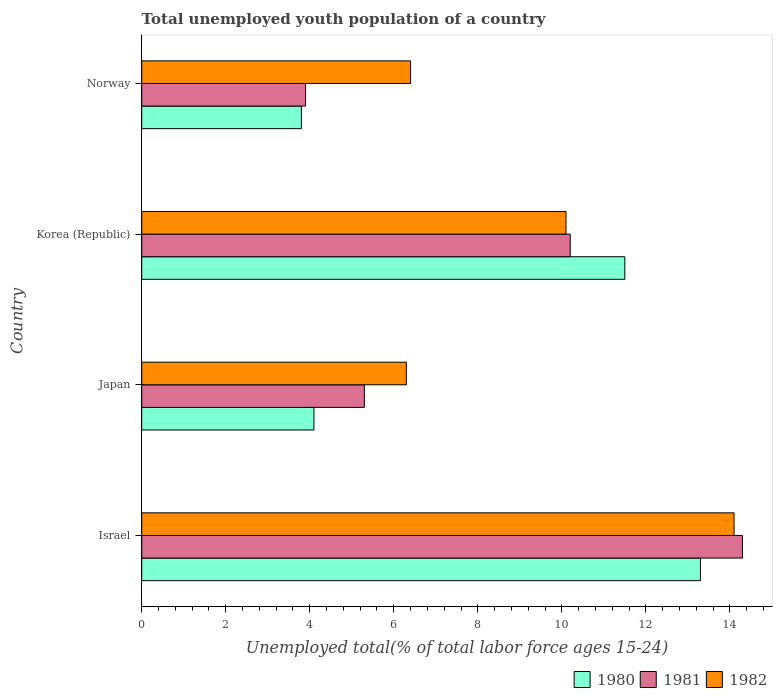How many different coloured bars are there?
Provide a succinct answer. 3. How many groups of bars are there?
Your answer should be compact. 4. Are the number of bars on each tick of the Y-axis equal?
Your response must be concise. Yes. How many bars are there on the 2nd tick from the top?
Your response must be concise. 3. In how many cases, is the number of bars for a given country not equal to the number of legend labels?
Your response must be concise. 0. What is the percentage of total unemployed youth population of a country in 1980 in Japan?
Make the answer very short. 4.1. Across all countries, what is the maximum percentage of total unemployed youth population of a country in 1980?
Provide a short and direct response. 13.3. Across all countries, what is the minimum percentage of total unemployed youth population of a country in 1982?
Make the answer very short. 6.3. What is the total percentage of total unemployed youth population of a country in 1982 in the graph?
Give a very brief answer. 36.9. What is the difference between the percentage of total unemployed youth population of a country in 1980 in Korea (Republic) and that in Norway?
Make the answer very short. 7.7. What is the difference between the percentage of total unemployed youth population of a country in 1981 in Israel and the percentage of total unemployed youth population of a country in 1980 in Japan?
Ensure brevity in your answer.  10.2. What is the average percentage of total unemployed youth population of a country in 1981 per country?
Offer a terse response. 8.43. What is the difference between the percentage of total unemployed youth population of a country in 1980 and percentage of total unemployed youth population of a country in 1981 in Japan?
Give a very brief answer. -1.2. In how many countries, is the percentage of total unemployed youth population of a country in 1980 greater than 14 %?
Offer a terse response. 0. What is the ratio of the percentage of total unemployed youth population of a country in 1982 in Japan to that in Korea (Republic)?
Provide a short and direct response. 0.62. What is the difference between the highest and the second highest percentage of total unemployed youth population of a country in 1981?
Your response must be concise. 4.1. What is the difference between the highest and the lowest percentage of total unemployed youth population of a country in 1980?
Ensure brevity in your answer.  9.5. What does the 2nd bar from the top in Japan represents?
Give a very brief answer. 1981. What does the 2nd bar from the bottom in Korea (Republic) represents?
Keep it short and to the point. 1981. How many bars are there?
Provide a succinct answer. 12. What is the difference between two consecutive major ticks on the X-axis?
Offer a terse response. 2. Are the values on the major ticks of X-axis written in scientific E-notation?
Provide a short and direct response. No. Does the graph contain any zero values?
Your answer should be very brief. No. Where does the legend appear in the graph?
Provide a short and direct response. Bottom right. What is the title of the graph?
Your answer should be very brief. Total unemployed youth population of a country. Does "1993" appear as one of the legend labels in the graph?
Ensure brevity in your answer.  No. What is the label or title of the X-axis?
Offer a terse response. Unemployed total(% of total labor force ages 15-24). What is the Unemployed total(% of total labor force ages 15-24) of 1980 in Israel?
Keep it short and to the point. 13.3. What is the Unemployed total(% of total labor force ages 15-24) in 1981 in Israel?
Your answer should be very brief. 14.3. What is the Unemployed total(% of total labor force ages 15-24) of 1982 in Israel?
Your answer should be compact. 14.1. What is the Unemployed total(% of total labor force ages 15-24) in 1980 in Japan?
Offer a terse response. 4.1. What is the Unemployed total(% of total labor force ages 15-24) in 1981 in Japan?
Provide a short and direct response. 5.3. What is the Unemployed total(% of total labor force ages 15-24) of 1982 in Japan?
Your answer should be compact. 6.3. What is the Unemployed total(% of total labor force ages 15-24) of 1981 in Korea (Republic)?
Provide a succinct answer. 10.2. What is the Unemployed total(% of total labor force ages 15-24) of 1982 in Korea (Republic)?
Make the answer very short. 10.1. What is the Unemployed total(% of total labor force ages 15-24) in 1980 in Norway?
Provide a succinct answer. 3.8. What is the Unemployed total(% of total labor force ages 15-24) of 1981 in Norway?
Offer a terse response. 3.9. What is the Unemployed total(% of total labor force ages 15-24) in 1982 in Norway?
Your answer should be very brief. 6.4. Across all countries, what is the maximum Unemployed total(% of total labor force ages 15-24) of 1980?
Offer a terse response. 13.3. Across all countries, what is the maximum Unemployed total(% of total labor force ages 15-24) of 1981?
Provide a short and direct response. 14.3. Across all countries, what is the maximum Unemployed total(% of total labor force ages 15-24) of 1982?
Provide a short and direct response. 14.1. Across all countries, what is the minimum Unemployed total(% of total labor force ages 15-24) of 1980?
Give a very brief answer. 3.8. Across all countries, what is the minimum Unemployed total(% of total labor force ages 15-24) in 1981?
Provide a succinct answer. 3.9. Across all countries, what is the minimum Unemployed total(% of total labor force ages 15-24) of 1982?
Your response must be concise. 6.3. What is the total Unemployed total(% of total labor force ages 15-24) of 1980 in the graph?
Make the answer very short. 32.7. What is the total Unemployed total(% of total labor force ages 15-24) of 1981 in the graph?
Your answer should be compact. 33.7. What is the total Unemployed total(% of total labor force ages 15-24) of 1982 in the graph?
Ensure brevity in your answer.  36.9. What is the difference between the Unemployed total(% of total labor force ages 15-24) in 1982 in Israel and that in Japan?
Ensure brevity in your answer.  7.8. What is the difference between the Unemployed total(% of total labor force ages 15-24) in 1980 in Israel and that in Korea (Republic)?
Provide a short and direct response. 1.8. What is the difference between the Unemployed total(% of total labor force ages 15-24) in 1981 in Israel and that in Korea (Republic)?
Ensure brevity in your answer.  4.1. What is the difference between the Unemployed total(% of total labor force ages 15-24) in 1982 in Israel and that in Korea (Republic)?
Offer a very short reply. 4. What is the difference between the Unemployed total(% of total labor force ages 15-24) in 1982 in Israel and that in Norway?
Your answer should be very brief. 7.7. What is the difference between the Unemployed total(% of total labor force ages 15-24) of 1981 in Japan and that in Korea (Republic)?
Make the answer very short. -4.9. What is the difference between the Unemployed total(% of total labor force ages 15-24) of 1982 in Japan and that in Korea (Republic)?
Give a very brief answer. -3.8. What is the difference between the Unemployed total(% of total labor force ages 15-24) of 1981 in Japan and that in Norway?
Your answer should be compact. 1.4. What is the difference between the Unemployed total(% of total labor force ages 15-24) of 1980 in Israel and the Unemployed total(% of total labor force ages 15-24) of 1981 in Japan?
Provide a succinct answer. 8. What is the difference between the Unemployed total(% of total labor force ages 15-24) of 1980 in Israel and the Unemployed total(% of total labor force ages 15-24) of 1982 in Japan?
Make the answer very short. 7. What is the difference between the Unemployed total(% of total labor force ages 15-24) of 1981 in Israel and the Unemployed total(% of total labor force ages 15-24) of 1982 in Japan?
Provide a short and direct response. 8. What is the difference between the Unemployed total(% of total labor force ages 15-24) of 1980 in Israel and the Unemployed total(% of total labor force ages 15-24) of 1981 in Korea (Republic)?
Keep it short and to the point. 3.1. What is the difference between the Unemployed total(% of total labor force ages 15-24) of 1980 in Israel and the Unemployed total(% of total labor force ages 15-24) of 1982 in Korea (Republic)?
Ensure brevity in your answer.  3.2. What is the difference between the Unemployed total(% of total labor force ages 15-24) in 1981 in Israel and the Unemployed total(% of total labor force ages 15-24) in 1982 in Korea (Republic)?
Offer a terse response. 4.2. What is the difference between the Unemployed total(% of total labor force ages 15-24) in 1980 in Israel and the Unemployed total(% of total labor force ages 15-24) in 1982 in Norway?
Keep it short and to the point. 6.9. What is the difference between the Unemployed total(% of total labor force ages 15-24) in 1981 in Israel and the Unemployed total(% of total labor force ages 15-24) in 1982 in Norway?
Offer a very short reply. 7.9. What is the difference between the Unemployed total(% of total labor force ages 15-24) in 1981 in Japan and the Unemployed total(% of total labor force ages 15-24) in 1982 in Korea (Republic)?
Keep it short and to the point. -4.8. What is the difference between the Unemployed total(% of total labor force ages 15-24) of 1980 in Japan and the Unemployed total(% of total labor force ages 15-24) of 1982 in Norway?
Your response must be concise. -2.3. What is the difference between the Unemployed total(% of total labor force ages 15-24) of 1980 in Korea (Republic) and the Unemployed total(% of total labor force ages 15-24) of 1981 in Norway?
Keep it short and to the point. 7.6. What is the difference between the Unemployed total(% of total labor force ages 15-24) in 1980 in Korea (Republic) and the Unemployed total(% of total labor force ages 15-24) in 1982 in Norway?
Your answer should be compact. 5.1. What is the difference between the Unemployed total(% of total labor force ages 15-24) in 1981 in Korea (Republic) and the Unemployed total(% of total labor force ages 15-24) in 1982 in Norway?
Provide a succinct answer. 3.8. What is the average Unemployed total(% of total labor force ages 15-24) in 1980 per country?
Offer a very short reply. 8.18. What is the average Unemployed total(% of total labor force ages 15-24) in 1981 per country?
Ensure brevity in your answer.  8.43. What is the average Unemployed total(% of total labor force ages 15-24) of 1982 per country?
Offer a very short reply. 9.22. What is the difference between the Unemployed total(% of total labor force ages 15-24) in 1980 and Unemployed total(% of total labor force ages 15-24) in 1981 in Israel?
Ensure brevity in your answer.  -1. What is the difference between the Unemployed total(% of total labor force ages 15-24) of 1980 and Unemployed total(% of total labor force ages 15-24) of 1982 in Israel?
Provide a short and direct response. -0.8. What is the difference between the Unemployed total(% of total labor force ages 15-24) of 1980 and Unemployed total(% of total labor force ages 15-24) of 1981 in Japan?
Your answer should be very brief. -1.2. What is the difference between the Unemployed total(% of total labor force ages 15-24) in 1980 and Unemployed total(% of total labor force ages 15-24) in 1981 in Korea (Republic)?
Your answer should be compact. 1.3. What is the difference between the Unemployed total(% of total labor force ages 15-24) in 1981 and Unemployed total(% of total labor force ages 15-24) in 1982 in Korea (Republic)?
Your response must be concise. 0.1. What is the difference between the Unemployed total(% of total labor force ages 15-24) in 1980 and Unemployed total(% of total labor force ages 15-24) in 1982 in Norway?
Ensure brevity in your answer.  -2.6. What is the ratio of the Unemployed total(% of total labor force ages 15-24) of 1980 in Israel to that in Japan?
Provide a succinct answer. 3.24. What is the ratio of the Unemployed total(% of total labor force ages 15-24) of 1981 in Israel to that in Japan?
Provide a short and direct response. 2.7. What is the ratio of the Unemployed total(% of total labor force ages 15-24) of 1982 in Israel to that in Japan?
Make the answer very short. 2.24. What is the ratio of the Unemployed total(% of total labor force ages 15-24) in 1980 in Israel to that in Korea (Republic)?
Ensure brevity in your answer.  1.16. What is the ratio of the Unemployed total(% of total labor force ages 15-24) of 1981 in Israel to that in Korea (Republic)?
Make the answer very short. 1.4. What is the ratio of the Unemployed total(% of total labor force ages 15-24) of 1982 in Israel to that in Korea (Republic)?
Offer a terse response. 1.4. What is the ratio of the Unemployed total(% of total labor force ages 15-24) of 1980 in Israel to that in Norway?
Keep it short and to the point. 3.5. What is the ratio of the Unemployed total(% of total labor force ages 15-24) of 1981 in Israel to that in Norway?
Keep it short and to the point. 3.67. What is the ratio of the Unemployed total(% of total labor force ages 15-24) of 1982 in Israel to that in Norway?
Provide a succinct answer. 2.2. What is the ratio of the Unemployed total(% of total labor force ages 15-24) of 1980 in Japan to that in Korea (Republic)?
Provide a succinct answer. 0.36. What is the ratio of the Unemployed total(% of total labor force ages 15-24) in 1981 in Japan to that in Korea (Republic)?
Make the answer very short. 0.52. What is the ratio of the Unemployed total(% of total labor force ages 15-24) in 1982 in Japan to that in Korea (Republic)?
Make the answer very short. 0.62. What is the ratio of the Unemployed total(% of total labor force ages 15-24) in 1980 in Japan to that in Norway?
Your response must be concise. 1.08. What is the ratio of the Unemployed total(% of total labor force ages 15-24) in 1981 in Japan to that in Norway?
Your answer should be very brief. 1.36. What is the ratio of the Unemployed total(% of total labor force ages 15-24) in 1982 in Japan to that in Norway?
Provide a succinct answer. 0.98. What is the ratio of the Unemployed total(% of total labor force ages 15-24) in 1980 in Korea (Republic) to that in Norway?
Ensure brevity in your answer.  3.03. What is the ratio of the Unemployed total(% of total labor force ages 15-24) in 1981 in Korea (Republic) to that in Norway?
Provide a succinct answer. 2.62. What is the ratio of the Unemployed total(% of total labor force ages 15-24) in 1982 in Korea (Republic) to that in Norway?
Make the answer very short. 1.58. What is the difference between the highest and the second highest Unemployed total(% of total labor force ages 15-24) in 1981?
Ensure brevity in your answer.  4.1. What is the difference between the highest and the second highest Unemployed total(% of total labor force ages 15-24) in 1982?
Offer a very short reply. 4. What is the difference between the highest and the lowest Unemployed total(% of total labor force ages 15-24) of 1980?
Keep it short and to the point. 9.5. 